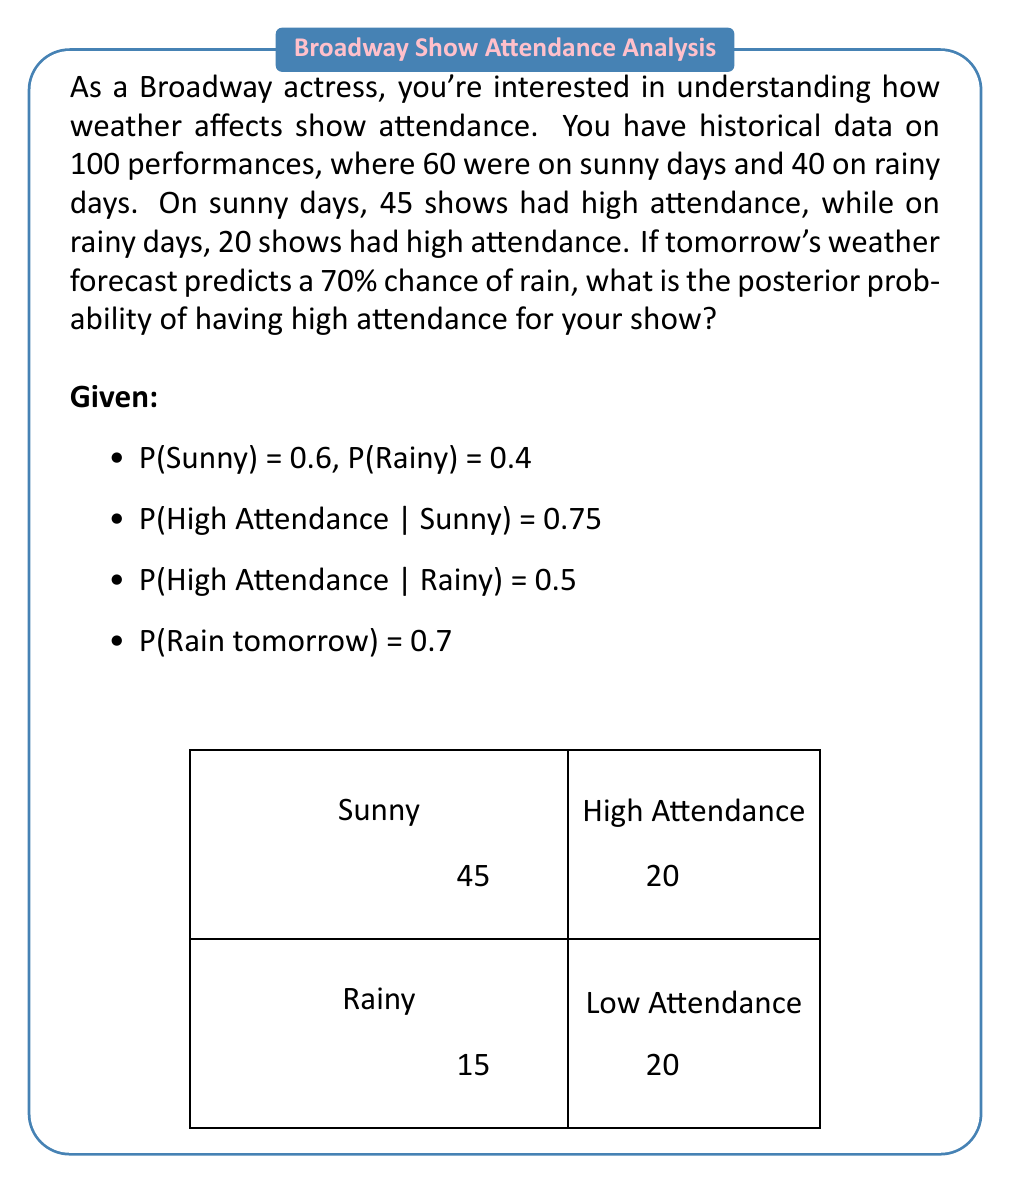Show me your answer to this math problem. Let's approach this problem using Bayes' theorem and the law of total probability:

1) First, we need to calculate P(High Attendance) using the law of total probability:

   P(H) = P(H|S)P(S) + P(H|R)P(R)
   = 0.75 * 0.6 + 0.5 * 0.4
   = 0.45 + 0.2 = 0.65

2) Now, let's use Bayes' theorem to find P(Rain|High Attendance):

   P(R|H) = P(H|R)P(R) / P(H)
   = (0.5 * 0.4) / 0.65
   ≈ 0.3077

3) We can now calculate P(Sunny|High Attendance):

   P(S|H) = 1 - P(R|H) ≈ 0.6923

4) Given the weather forecast for tomorrow, we can use the law of total probability again:

   P(H_tomorrow) = P(H|R)P(R_tomorrow) + P(H|S)P(S_tomorrow)
   = 0.5 * 0.7 + 0.75 * 0.3
   = 0.35 + 0.225
   = 0.575

Therefore, the posterior probability of having high attendance tomorrow, given the 70% chance of rain, is approximately 0.575 or 57.5%.
Answer: 0.575 